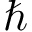<formula> <loc_0><loc_0><loc_500><loc_500>\hbar</formula> 